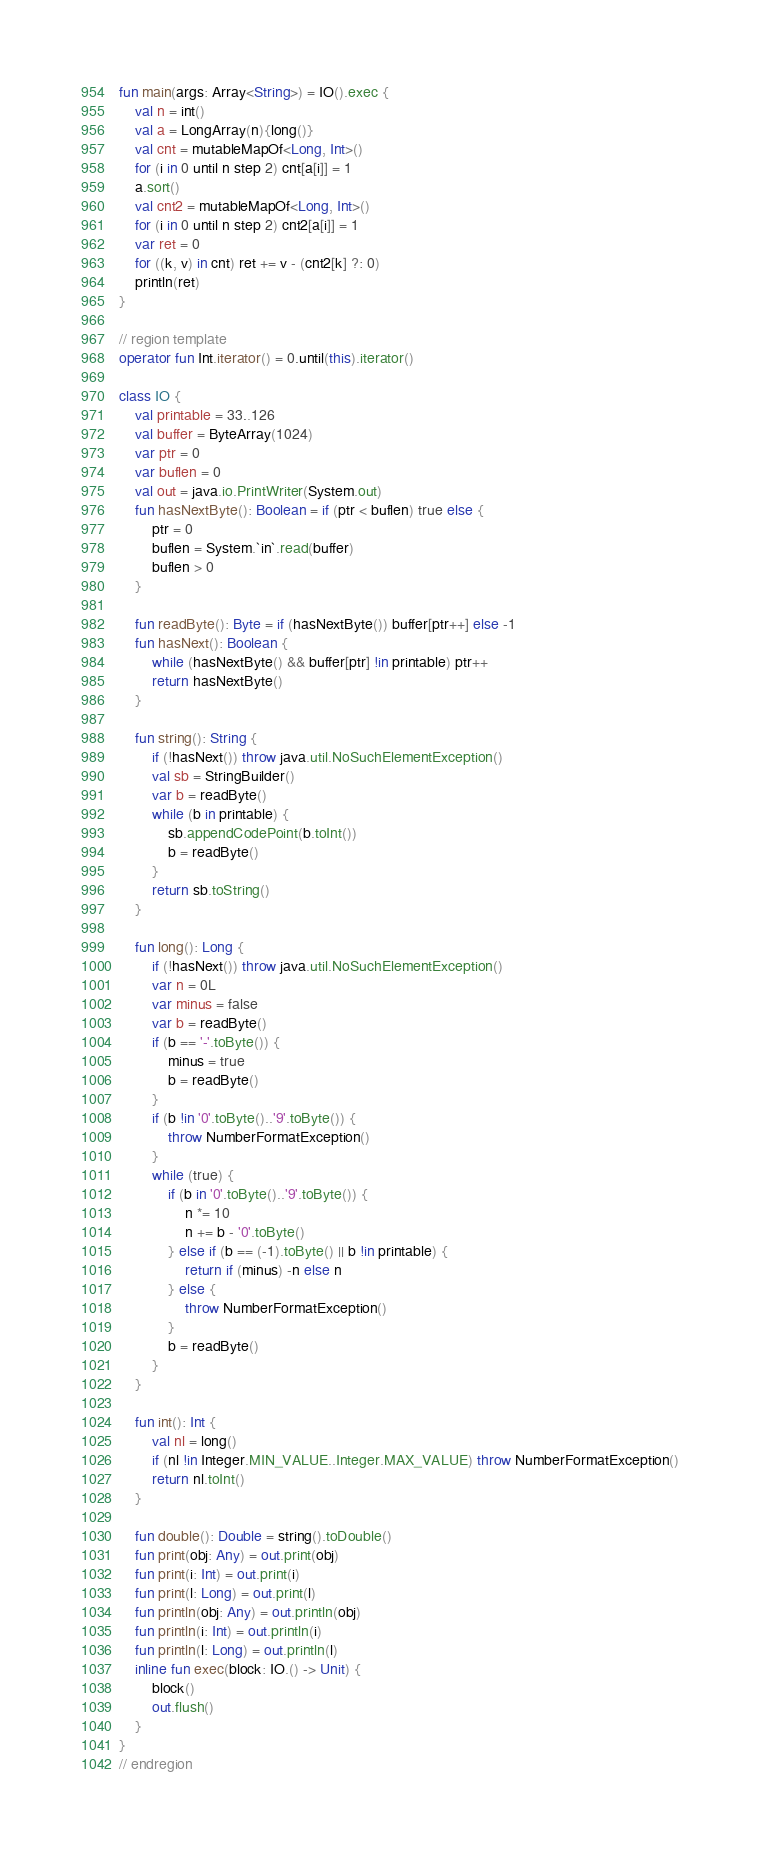Convert code to text. <code><loc_0><loc_0><loc_500><loc_500><_Kotlin_>fun main(args: Array<String>) = IO().exec {
    val n = int()
    val a = LongArray(n){long()}
    val cnt = mutableMapOf<Long, Int>()
    for (i in 0 until n step 2) cnt[a[i]] = 1
    a.sort()
    val cnt2 = mutableMapOf<Long, Int>()
    for (i in 0 until n step 2) cnt2[a[i]] = 1
    var ret = 0
    for ((k, v) in cnt) ret += v - (cnt2[k] ?: 0)
    println(ret)
}

// region template
operator fun Int.iterator() = 0.until(this).iterator()

class IO {
    val printable = 33..126
    val buffer = ByteArray(1024)
    var ptr = 0
    var buflen = 0
    val out = java.io.PrintWriter(System.out)
    fun hasNextByte(): Boolean = if (ptr < buflen) true else {
        ptr = 0
        buflen = System.`in`.read(buffer)
        buflen > 0
    }

    fun readByte(): Byte = if (hasNextByte()) buffer[ptr++] else -1
    fun hasNext(): Boolean {
        while (hasNextByte() && buffer[ptr] !in printable) ptr++
        return hasNextByte()
    }

    fun string(): String {
        if (!hasNext()) throw java.util.NoSuchElementException()
        val sb = StringBuilder()
        var b = readByte()
        while (b in printable) {
            sb.appendCodePoint(b.toInt())
            b = readByte()
        }
        return sb.toString()
    }

    fun long(): Long {
        if (!hasNext()) throw java.util.NoSuchElementException()
        var n = 0L
        var minus = false
        var b = readByte()
        if (b == '-'.toByte()) {
            minus = true
            b = readByte()
        }
        if (b !in '0'.toByte()..'9'.toByte()) {
            throw NumberFormatException()
        }
        while (true) {
            if (b in '0'.toByte()..'9'.toByte()) {
                n *= 10
                n += b - '0'.toByte()
            } else if (b == (-1).toByte() || b !in printable) {
                return if (minus) -n else n
            } else {
                throw NumberFormatException()
            }
            b = readByte()
        }
    }

    fun int(): Int {
        val nl = long()
        if (nl !in Integer.MIN_VALUE..Integer.MAX_VALUE) throw NumberFormatException()
        return nl.toInt()
    }

    fun double(): Double = string().toDouble()
    fun print(obj: Any) = out.print(obj)
    fun print(i: Int) = out.print(i)
    fun print(l: Long) = out.print(l)
    fun println(obj: Any) = out.println(obj)
    fun println(i: Int) = out.println(i)
    fun println(l: Long) = out.println(l)
    inline fun exec(block: IO.() -> Unit) {
        block()
        out.flush()
    }
}
// endregion</code> 